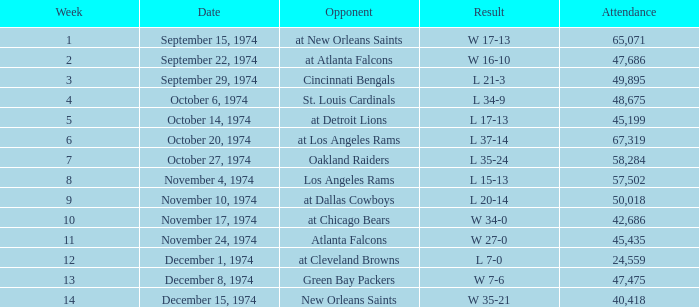How many people attended the match when they played at detroit lions? 45199.0. 